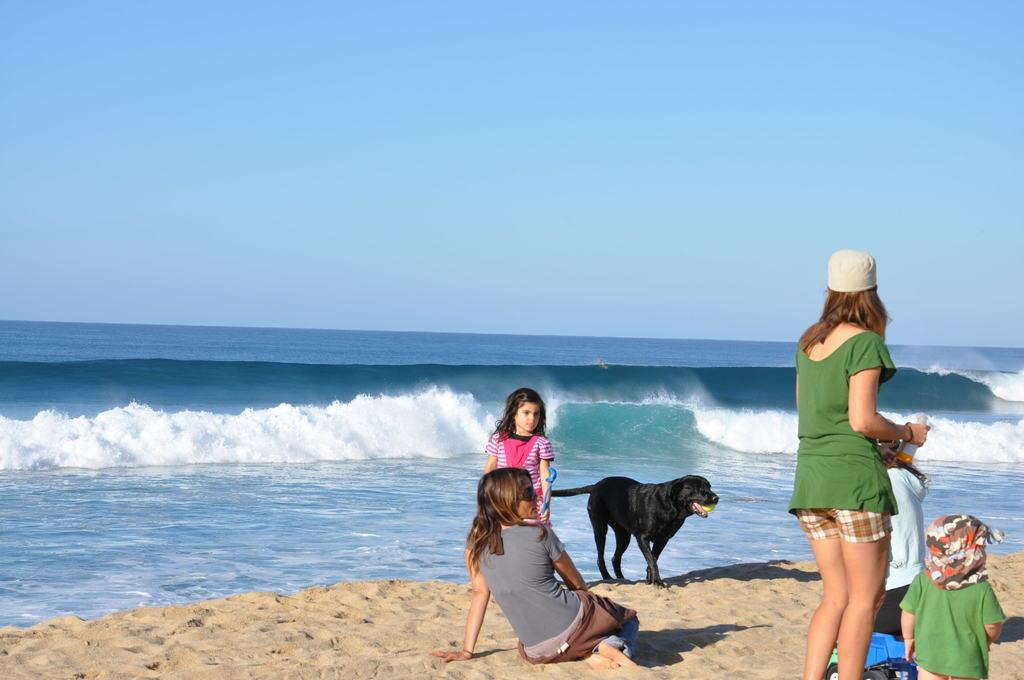What type of natural feature is visible in the image? There is an ocean in the image. What is the land surface near the ocean? There is a sand beach in the image. What are people doing on the sand beach? People are sitting and standing on the sand beach. What animal is present in the image? A dog is present in the image. What is the dog doing in the image? The dog is carrying a ball in its mouth. Where is the boundary between the ocean and the land in the image? There is no specific boundary between the ocean and the land visible in the image; it is a gradual transition from sand beach to ocean. Can you see any fairies flying over the ocean in the image? There are no fairies present in the image; it features an ocean, a sand beach, people, and a dog. 